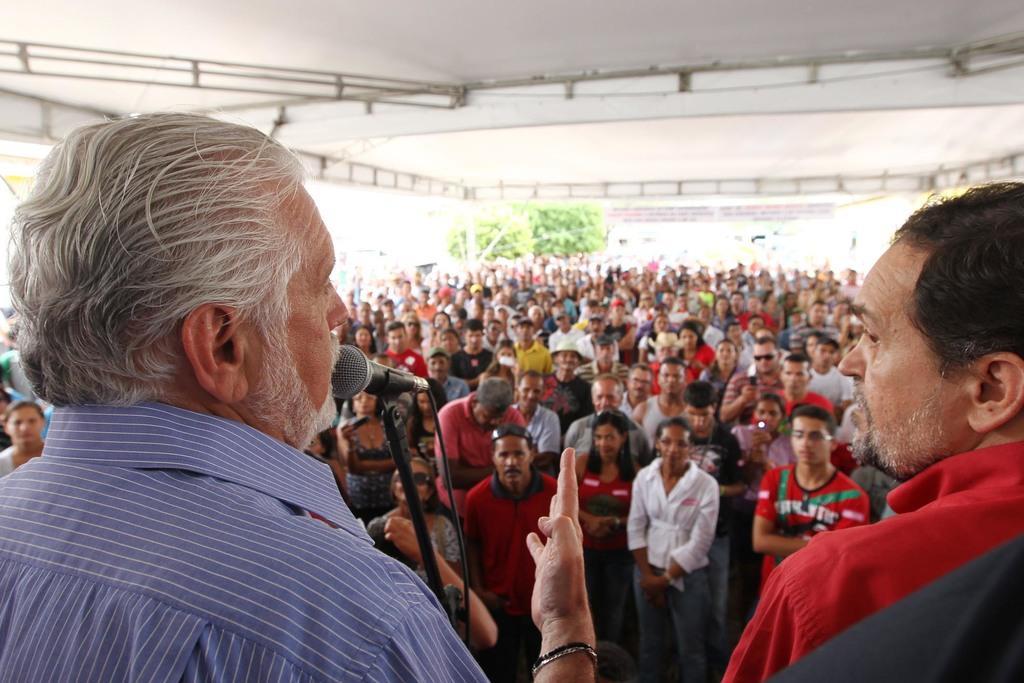Describe this image in one or two sentences. In this image there is a man standing in front of a mike, in the background there are people standing, at the top there is a roof. 